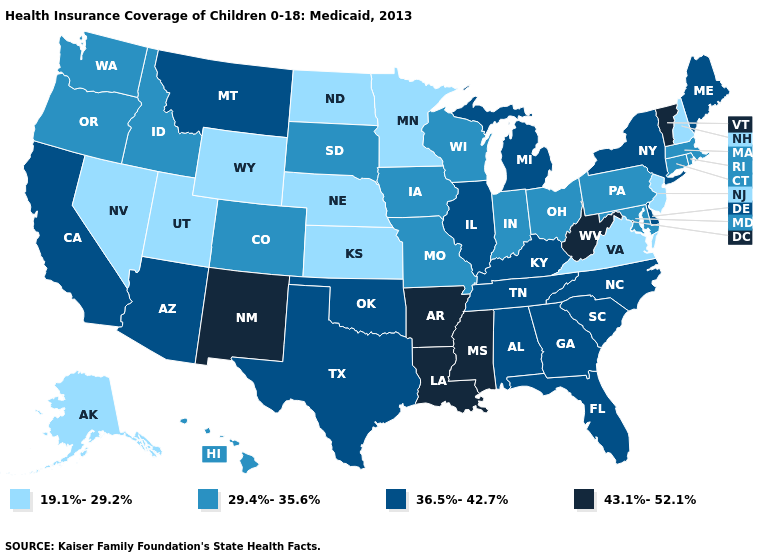Which states have the lowest value in the USA?
Concise answer only. Alaska, Kansas, Minnesota, Nebraska, Nevada, New Hampshire, New Jersey, North Dakota, Utah, Virginia, Wyoming. Does Tennessee have a higher value than Kentucky?
Keep it brief. No. Which states have the highest value in the USA?
Quick response, please. Arkansas, Louisiana, Mississippi, New Mexico, Vermont, West Virginia. Does South Dakota have the same value as New Mexico?
Keep it brief. No. Name the states that have a value in the range 36.5%-42.7%?
Answer briefly. Alabama, Arizona, California, Delaware, Florida, Georgia, Illinois, Kentucky, Maine, Michigan, Montana, New York, North Carolina, Oklahoma, South Carolina, Tennessee, Texas. Does Utah have a lower value than Idaho?
Write a very short answer. Yes. Name the states that have a value in the range 29.4%-35.6%?
Write a very short answer. Colorado, Connecticut, Hawaii, Idaho, Indiana, Iowa, Maryland, Massachusetts, Missouri, Ohio, Oregon, Pennsylvania, Rhode Island, South Dakota, Washington, Wisconsin. Name the states that have a value in the range 43.1%-52.1%?
Answer briefly. Arkansas, Louisiana, Mississippi, New Mexico, Vermont, West Virginia. What is the value of Arkansas?
Quick response, please. 43.1%-52.1%. Among the states that border Nebraska , does Kansas have the highest value?
Be succinct. No. Which states have the highest value in the USA?
Answer briefly. Arkansas, Louisiana, Mississippi, New Mexico, Vermont, West Virginia. Does Nevada have a lower value than Rhode Island?
Write a very short answer. Yes. How many symbols are there in the legend?
Quick response, please. 4. Name the states that have a value in the range 43.1%-52.1%?
Quick response, please. Arkansas, Louisiana, Mississippi, New Mexico, Vermont, West Virginia. What is the value of Maryland?
Be succinct. 29.4%-35.6%. 